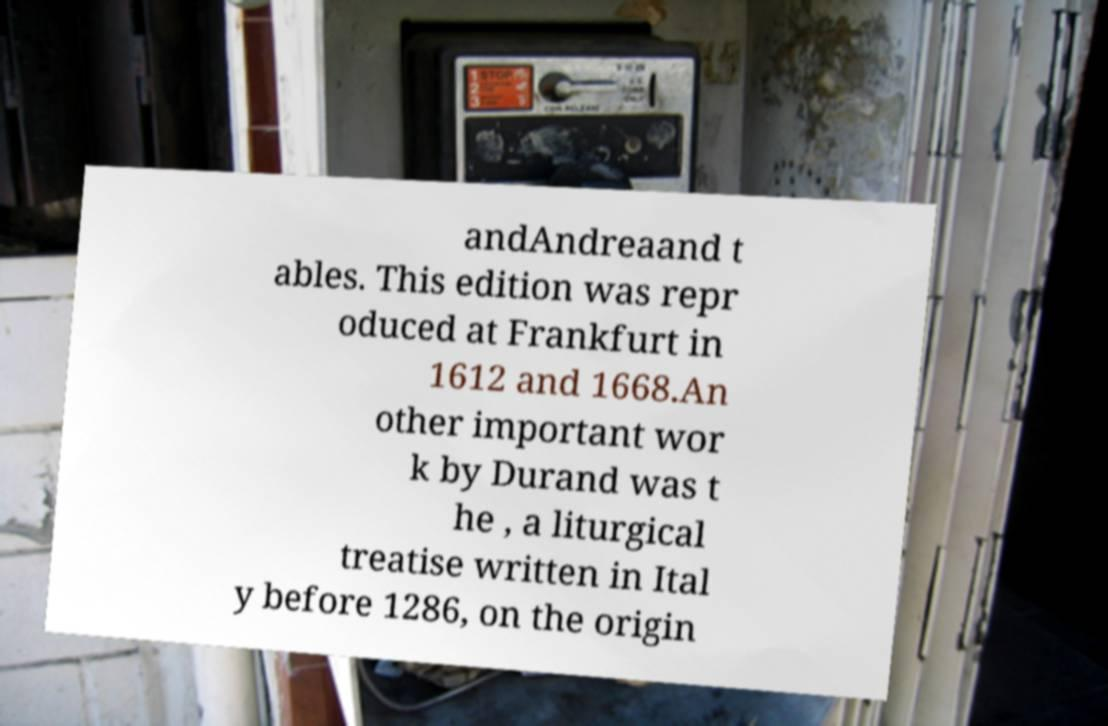For documentation purposes, I need the text within this image transcribed. Could you provide that? andAndreaand t ables. This edition was repr oduced at Frankfurt in 1612 and 1668.An other important wor k by Durand was t he , a liturgical treatise written in Ital y before 1286, on the origin 